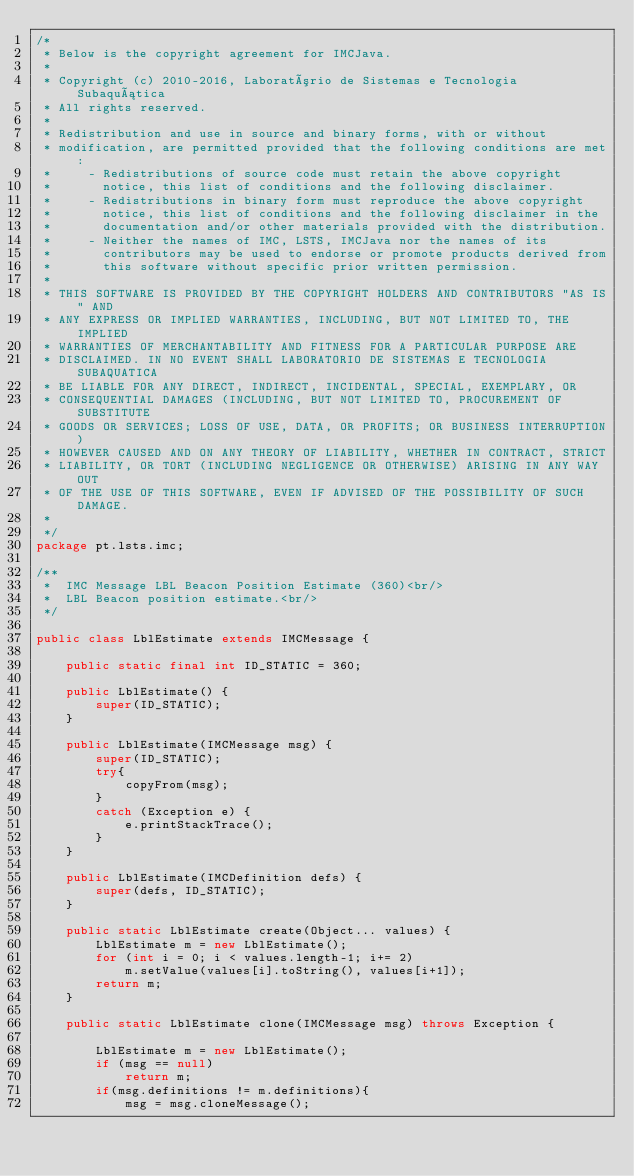<code> <loc_0><loc_0><loc_500><loc_500><_Java_>/*
 * Below is the copyright agreement for IMCJava.
 * 
 * Copyright (c) 2010-2016, Laboratório de Sistemas e Tecnologia Subaquática
 * All rights reserved.
 * 
 * Redistribution and use in source and binary forms, with or without
 * modification, are permitted provided that the following conditions are met:
 *     - Redistributions of source code must retain the above copyright
 *       notice, this list of conditions and the following disclaimer.
 *     - Redistributions in binary form must reproduce the above copyright
 *       notice, this list of conditions and the following disclaimer in the
 *       documentation and/or other materials provided with the distribution.
 *     - Neither the names of IMC, LSTS, IMCJava nor the names of its 
 *       contributors may be used to endorse or promote products derived from 
 *       this software without specific prior written permission.
 * 
 * THIS SOFTWARE IS PROVIDED BY THE COPYRIGHT HOLDERS AND CONTRIBUTORS "AS IS" AND
 * ANY EXPRESS OR IMPLIED WARRANTIES, INCLUDING, BUT NOT LIMITED TO, THE IMPLIED
 * WARRANTIES OF MERCHANTABILITY AND FITNESS FOR A PARTICULAR PURPOSE ARE
 * DISCLAIMED. IN NO EVENT SHALL LABORATORIO DE SISTEMAS E TECNOLOGIA SUBAQUATICA
 * BE LIABLE FOR ANY DIRECT, INDIRECT, INCIDENTAL, SPECIAL, EXEMPLARY, OR
 * CONSEQUENTIAL DAMAGES (INCLUDING, BUT NOT LIMITED TO, PROCUREMENT OF SUBSTITUTE 
 * GOODS OR SERVICES; LOSS OF USE, DATA, OR PROFITS; OR BUSINESS INTERRUPTION) 
 * HOWEVER CAUSED AND ON ANY THEORY OF LIABILITY, WHETHER IN CONTRACT, STRICT 
 * LIABILITY, OR TORT (INCLUDING NEGLIGENCE OR OTHERWISE) ARISING IN ANY WAY OUT 
 * OF THE USE OF THIS SOFTWARE, EVEN IF ADVISED OF THE POSSIBILITY OF SUCH DAMAGE.
 * 
 */
package pt.lsts.imc;

/**
 *  IMC Message LBL Beacon Position Estimate (360)<br/>
 *  LBL Beacon position estimate.<br/>
 */

public class LblEstimate extends IMCMessage {

	public static final int ID_STATIC = 360;

	public LblEstimate() {
		super(ID_STATIC);
	}

	public LblEstimate(IMCMessage msg) {
		super(ID_STATIC);
		try{
			copyFrom(msg);
		}
		catch (Exception e) {
			e.printStackTrace();
		}
	}

	public LblEstimate(IMCDefinition defs) {
		super(defs, ID_STATIC);
	}

	public static LblEstimate create(Object... values) {
		LblEstimate m = new LblEstimate();
		for (int i = 0; i < values.length-1; i+= 2)
			m.setValue(values[i].toString(), values[i+1]);
		return m;
	}

	public static LblEstimate clone(IMCMessage msg) throws Exception {

		LblEstimate m = new LblEstimate();
		if (msg == null)
			return m;
		if(msg.definitions != m.definitions){
			msg = msg.cloneMessage();</code> 